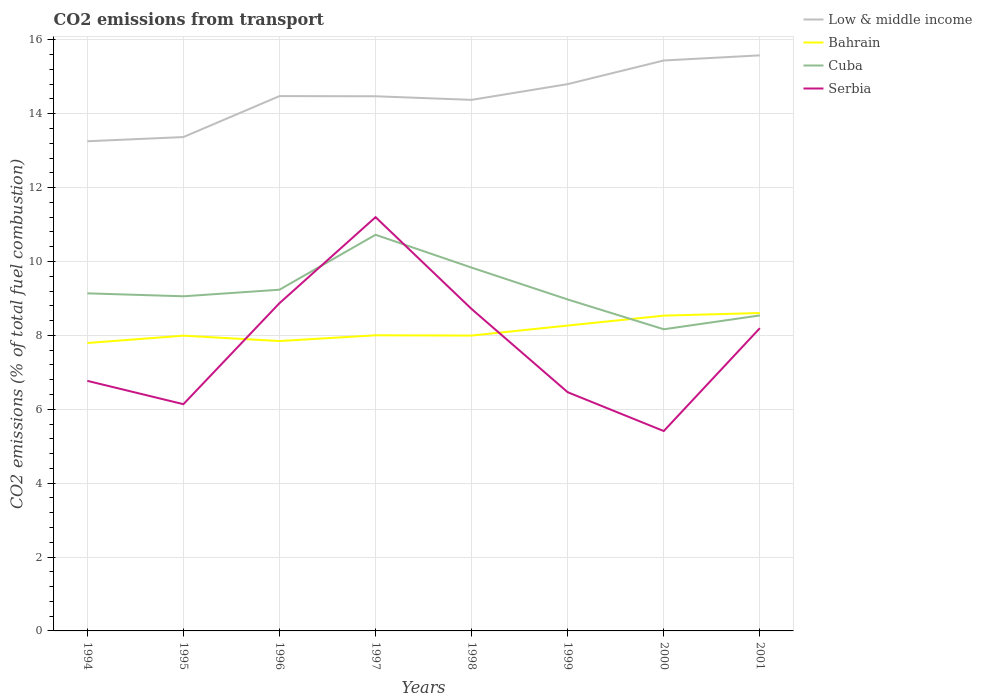Does the line corresponding to Bahrain intersect with the line corresponding to Serbia?
Keep it short and to the point. Yes. Is the number of lines equal to the number of legend labels?
Your answer should be very brief. Yes. Across all years, what is the maximum total CO2 emitted in Bahrain?
Offer a terse response. 7.79. What is the total total CO2 emitted in Serbia in the graph?
Offer a terse response. 2.49. What is the difference between the highest and the second highest total CO2 emitted in Cuba?
Make the answer very short. 2.56. How many years are there in the graph?
Keep it short and to the point. 8. What is the difference between two consecutive major ticks on the Y-axis?
Your response must be concise. 2. Are the values on the major ticks of Y-axis written in scientific E-notation?
Make the answer very short. No. Does the graph contain any zero values?
Make the answer very short. No. How are the legend labels stacked?
Make the answer very short. Vertical. What is the title of the graph?
Offer a very short reply. CO2 emissions from transport. What is the label or title of the Y-axis?
Keep it short and to the point. CO2 emissions (% of total fuel combustion). What is the CO2 emissions (% of total fuel combustion) in Low & middle income in 1994?
Your answer should be very brief. 13.26. What is the CO2 emissions (% of total fuel combustion) of Bahrain in 1994?
Ensure brevity in your answer.  7.79. What is the CO2 emissions (% of total fuel combustion) of Cuba in 1994?
Your answer should be compact. 9.14. What is the CO2 emissions (% of total fuel combustion) in Serbia in 1994?
Your response must be concise. 6.77. What is the CO2 emissions (% of total fuel combustion) of Low & middle income in 1995?
Give a very brief answer. 13.37. What is the CO2 emissions (% of total fuel combustion) of Bahrain in 1995?
Provide a short and direct response. 7.99. What is the CO2 emissions (% of total fuel combustion) in Cuba in 1995?
Ensure brevity in your answer.  9.06. What is the CO2 emissions (% of total fuel combustion) of Serbia in 1995?
Provide a succinct answer. 6.14. What is the CO2 emissions (% of total fuel combustion) in Low & middle income in 1996?
Provide a succinct answer. 14.48. What is the CO2 emissions (% of total fuel combustion) of Bahrain in 1996?
Provide a succinct answer. 7.85. What is the CO2 emissions (% of total fuel combustion) in Cuba in 1996?
Offer a terse response. 9.24. What is the CO2 emissions (% of total fuel combustion) of Serbia in 1996?
Your response must be concise. 8.87. What is the CO2 emissions (% of total fuel combustion) in Low & middle income in 1997?
Ensure brevity in your answer.  14.47. What is the CO2 emissions (% of total fuel combustion) of Bahrain in 1997?
Your answer should be very brief. 8. What is the CO2 emissions (% of total fuel combustion) of Cuba in 1997?
Your response must be concise. 10.72. What is the CO2 emissions (% of total fuel combustion) of Serbia in 1997?
Offer a very short reply. 11.2. What is the CO2 emissions (% of total fuel combustion) in Low & middle income in 1998?
Your answer should be compact. 14.38. What is the CO2 emissions (% of total fuel combustion) of Bahrain in 1998?
Your answer should be compact. 8. What is the CO2 emissions (% of total fuel combustion) in Cuba in 1998?
Make the answer very short. 9.83. What is the CO2 emissions (% of total fuel combustion) of Serbia in 1998?
Make the answer very short. 8.71. What is the CO2 emissions (% of total fuel combustion) in Low & middle income in 1999?
Make the answer very short. 14.8. What is the CO2 emissions (% of total fuel combustion) in Bahrain in 1999?
Keep it short and to the point. 8.27. What is the CO2 emissions (% of total fuel combustion) in Cuba in 1999?
Make the answer very short. 8.97. What is the CO2 emissions (% of total fuel combustion) in Serbia in 1999?
Offer a terse response. 6.46. What is the CO2 emissions (% of total fuel combustion) of Low & middle income in 2000?
Ensure brevity in your answer.  15.44. What is the CO2 emissions (% of total fuel combustion) in Bahrain in 2000?
Make the answer very short. 8.53. What is the CO2 emissions (% of total fuel combustion) in Cuba in 2000?
Offer a very short reply. 8.17. What is the CO2 emissions (% of total fuel combustion) of Serbia in 2000?
Your response must be concise. 5.41. What is the CO2 emissions (% of total fuel combustion) in Low & middle income in 2001?
Give a very brief answer. 15.58. What is the CO2 emissions (% of total fuel combustion) in Bahrain in 2001?
Your response must be concise. 8.61. What is the CO2 emissions (% of total fuel combustion) of Cuba in 2001?
Provide a short and direct response. 8.54. What is the CO2 emissions (% of total fuel combustion) in Serbia in 2001?
Offer a terse response. 8.2. Across all years, what is the maximum CO2 emissions (% of total fuel combustion) in Low & middle income?
Your response must be concise. 15.58. Across all years, what is the maximum CO2 emissions (% of total fuel combustion) in Bahrain?
Give a very brief answer. 8.61. Across all years, what is the maximum CO2 emissions (% of total fuel combustion) in Cuba?
Keep it short and to the point. 10.72. Across all years, what is the maximum CO2 emissions (% of total fuel combustion) in Serbia?
Provide a succinct answer. 11.2. Across all years, what is the minimum CO2 emissions (% of total fuel combustion) of Low & middle income?
Ensure brevity in your answer.  13.26. Across all years, what is the minimum CO2 emissions (% of total fuel combustion) in Bahrain?
Keep it short and to the point. 7.79. Across all years, what is the minimum CO2 emissions (% of total fuel combustion) in Cuba?
Offer a terse response. 8.17. Across all years, what is the minimum CO2 emissions (% of total fuel combustion) of Serbia?
Your answer should be compact. 5.41. What is the total CO2 emissions (% of total fuel combustion) of Low & middle income in the graph?
Your answer should be compact. 115.77. What is the total CO2 emissions (% of total fuel combustion) of Bahrain in the graph?
Provide a short and direct response. 65.04. What is the total CO2 emissions (% of total fuel combustion) in Cuba in the graph?
Offer a very short reply. 73.67. What is the total CO2 emissions (% of total fuel combustion) of Serbia in the graph?
Your answer should be very brief. 61.76. What is the difference between the CO2 emissions (% of total fuel combustion) in Low & middle income in 1994 and that in 1995?
Ensure brevity in your answer.  -0.11. What is the difference between the CO2 emissions (% of total fuel combustion) in Bahrain in 1994 and that in 1995?
Ensure brevity in your answer.  -0.2. What is the difference between the CO2 emissions (% of total fuel combustion) in Cuba in 1994 and that in 1995?
Your response must be concise. 0.08. What is the difference between the CO2 emissions (% of total fuel combustion) of Serbia in 1994 and that in 1995?
Give a very brief answer. 0.63. What is the difference between the CO2 emissions (% of total fuel combustion) in Low & middle income in 1994 and that in 1996?
Your answer should be very brief. -1.22. What is the difference between the CO2 emissions (% of total fuel combustion) of Bahrain in 1994 and that in 1996?
Make the answer very short. -0.05. What is the difference between the CO2 emissions (% of total fuel combustion) of Cuba in 1994 and that in 1996?
Ensure brevity in your answer.  -0.1. What is the difference between the CO2 emissions (% of total fuel combustion) in Serbia in 1994 and that in 1996?
Provide a succinct answer. -2.1. What is the difference between the CO2 emissions (% of total fuel combustion) in Low & middle income in 1994 and that in 1997?
Ensure brevity in your answer.  -1.22. What is the difference between the CO2 emissions (% of total fuel combustion) of Bahrain in 1994 and that in 1997?
Offer a very short reply. -0.21. What is the difference between the CO2 emissions (% of total fuel combustion) in Cuba in 1994 and that in 1997?
Your answer should be very brief. -1.59. What is the difference between the CO2 emissions (% of total fuel combustion) of Serbia in 1994 and that in 1997?
Offer a very short reply. -4.43. What is the difference between the CO2 emissions (% of total fuel combustion) in Low & middle income in 1994 and that in 1998?
Your response must be concise. -1.12. What is the difference between the CO2 emissions (% of total fuel combustion) of Bahrain in 1994 and that in 1998?
Keep it short and to the point. -0.2. What is the difference between the CO2 emissions (% of total fuel combustion) of Cuba in 1994 and that in 1998?
Your answer should be compact. -0.7. What is the difference between the CO2 emissions (% of total fuel combustion) in Serbia in 1994 and that in 1998?
Your answer should be very brief. -1.94. What is the difference between the CO2 emissions (% of total fuel combustion) of Low & middle income in 1994 and that in 1999?
Your answer should be very brief. -1.55. What is the difference between the CO2 emissions (% of total fuel combustion) of Bahrain in 1994 and that in 1999?
Make the answer very short. -0.47. What is the difference between the CO2 emissions (% of total fuel combustion) in Cuba in 1994 and that in 1999?
Ensure brevity in your answer.  0.17. What is the difference between the CO2 emissions (% of total fuel combustion) of Serbia in 1994 and that in 1999?
Ensure brevity in your answer.  0.31. What is the difference between the CO2 emissions (% of total fuel combustion) of Low & middle income in 1994 and that in 2000?
Your response must be concise. -2.19. What is the difference between the CO2 emissions (% of total fuel combustion) of Bahrain in 1994 and that in 2000?
Make the answer very short. -0.74. What is the difference between the CO2 emissions (% of total fuel combustion) in Cuba in 1994 and that in 2000?
Make the answer very short. 0.97. What is the difference between the CO2 emissions (% of total fuel combustion) in Serbia in 1994 and that in 2000?
Keep it short and to the point. 1.36. What is the difference between the CO2 emissions (% of total fuel combustion) of Low & middle income in 1994 and that in 2001?
Your answer should be compact. -2.33. What is the difference between the CO2 emissions (% of total fuel combustion) of Bahrain in 1994 and that in 2001?
Offer a very short reply. -0.81. What is the difference between the CO2 emissions (% of total fuel combustion) in Cuba in 1994 and that in 2001?
Provide a short and direct response. 0.6. What is the difference between the CO2 emissions (% of total fuel combustion) in Serbia in 1994 and that in 2001?
Give a very brief answer. -1.43. What is the difference between the CO2 emissions (% of total fuel combustion) of Low & middle income in 1995 and that in 1996?
Ensure brevity in your answer.  -1.11. What is the difference between the CO2 emissions (% of total fuel combustion) in Bahrain in 1995 and that in 1996?
Your answer should be compact. 0.15. What is the difference between the CO2 emissions (% of total fuel combustion) in Cuba in 1995 and that in 1996?
Your answer should be compact. -0.18. What is the difference between the CO2 emissions (% of total fuel combustion) in Serbia in 1995 and that in 1996?
Your response must be concise. -2.73. What is the difference between the CO2 emissions (% of total fuel combustion) of Low & middle income in 1995 and that in 1997?
Make the answer very short. -1.1. What is the difference between the CO2 emissions (% of total fuel combustion) of Bahrain in 1995 and that in 1997?
Provide a succinct answer. -0.01. What is the difference between the CO2 emissions (% of total fuel combustion) of Cuba in 1995 and that in 1997?
Offer a very short reply. -1.67. What is the difference between the CO2 emissions (% of total fuel combustion) in Serbia in 1995 and that in 1997?
Your response must be concise. -5.06. What is the difference between the CO2 emissions (% of total fuel combustion) in Low & middle income in 1995 and that in 1998?
Provide a short and direct response. -1.01. What is the difference between the CO2 emissions (% of total fuel combustion) of Bahrain in 1995 and that in 1998?
Offer a terse response. -0. What is the difference between the CO2 emissions (% of total fuel combustion) in Cuba in 1995 and that in 1998?
Your response must be concise. -0.78. What is the difference between the CO2 emissions (% of total fuel combustion) in Serbia in 1995 and that in 1998?
Provide a short and direct response. -2.58. What is the difference between the CO2 emissions (% of total fuel combustion) of Low & middle income in 1995 and that in 1999?
Provide a short and direct response. -1.43. What is the difference between the CO2 emissions (% of total fuel combustion) in Bahrain in 1995 and that in 1999?
Make the answer very short. -0.27. What is the difference between the CO2 emissions (% of total fuel combustion) of Cuba in 1995 and that in 1999?
Ensure brevity in your answer.  0.09. What is the difference between the CO2 emissions (% of total fuel combustion) in Serbia in 1995 and that in 1999?
Offer a very short reply. -0.32. What is the difference between the CO2 emissions (% of total fuel combustion) of Low & middle income in 1995 and that in 2000?
Give a very brief answer. -2.07. What is the difference between the CO2 emissions (% of total fuel combustion) in Bahrain in 1995 and that in 2000?
Make the answer very short. -0.54. What is the difference between the CO2 emissions (% of total fuel combustion) of Cuba in 1995 and that in 2000?
Provide a succinct answer. 0.89. What is the difference between the CO2 emissions (% of total fuel combustion) in Serbia in 1995 and that in 2000?
Provide a succinct answer. 0.73. What is the difference between the CO2 emissions (% of total fuel combustion) in Low & middle income in 1995 and that in 2001?
Provide a succinct answer. -2.21. What is the difference between the CO2 emissions (% of total fuel combustion) in Bahrain in 1995 and that in 2001?
Provide a succinct answer. -0.61. What is the difference between the CO2 emissions (% of total fuel combustion) in Cuba in 1995 and that in 2001?
Provide a succinct answer. 0.52. What is the difference between the CO2 emissions (% of total fuel combustion) in Serbia in 1995 and that in 2001?
Your answer should be compact. -2.06. What is the difference between the CO2 emissions (% of total fuel combustion) of Low & middle income in 1996 and that in 1997?
Make the answer very short. 0. What is the difference between the CO2 emissions (% of total fuel combustion) in Bahrain in 1996 and that in 1997?
Your answer should be compact. -0.16. What is the difference between the CO2 emissions (% of total fuel combustion) of Cuba in 1996 and that in 1997?
Provide a short and direct response. -1.49. What is the difference between the CO2 emissions (% of total fuel combustion) of Serbia in 1996 and that in 1997?
Offer a terse response. -2.33. What is the difference between the CO2 emissions (% of total fuel combustion) of Low & middle income in 1996 and that in 1998?
Your answer should be very brief. 0.1. What is the difference between the CO2 emissions (% of total fuel combustion) in Bahrain in 1996 and that in 1998?
Give a very brief answer. -0.15. What is the difference between the CO2 emissions (% of total fuel combustion) in Cuba in 1996 and that in 1998?
Offer a terse response. -0.6. What is the difference between the CO2 emissions (% of total fuel combustion) in Serbia in 1996 and that in 1998?
Make the answer very short. 0.16. What is the difference between the CO2 emissions (% of total fuel combustion) in Low & middle income in 1996 and that in 1999?
Give a very brief answer. -0.32. What is the difference between the CO2 emissions (% of total fuel combustion) in Bahrain in 1996 and that in 1999?
Your response must be concise. -0.42. What is the difference between the CO2 emissions (% of total fuel combustion) in Cuba in 1996 and that in 1999?
Ensure brevity in your answer.  0.26. What is the difference between the CO2 emissions (% of total fuel combustion) in Serbia in 1996 and that in 1999?
Your answer should be compact. 2.41. What is the difference between the CO2 emissions (% of total fuel combustion) in Low & middle income in 1996 and that in 2000?
Make the answer very short. -0.96. What is the difference between the CO2 emissions (% of total fuel combustion) of Bahrain in 1996 and that in 2000?
Give a very brief answer. -0.69. What is the difference between the CO2 emissions (% of total fuel combustion) in Cuba in 1996 and that in 2000?
Offer a terse response. 1.07. What is the difference between the CO2 emissions (% of total fuel combustion) in Serbia in 1996 and that in 2000?
Provide a succinct answer. 3.46. What is the difference between the CO2 emissions (% of total fuel combustion) of Low & middle income in 1996 and that in 2001?
Offer a terse response. -1.1. What is the difference between the CO2 emissions (% of total fuel combustion) in Bahrain in 1996 and that in 2001?
Offer a terse response. -0.76. What is the difference between the CO2 emissions (% of total fuel combustion) in Cuba in 1996 and that in 2001?
Your answer should be very brief. 0.7. What is the difference between the CO2 emissions (% of total fuel combustion) in Serbia in 1996 and that in 2001?
Your answer should be compact. 0.68. What is the difference between the CO2 emissions (% of total fuel combustion) of Low & middle income in 1997 and that in 1998?
Ensure brevity in your answer.  0.1. What is the difference between the CO2 emissions (% of total fuel combustion) in Bahrain in 1997 and that in 1998?
Provide a succinct answer. 0.01. What is the difference between the CO2 emissions (% of total fuel combustion) of Cuba in 1997 and that in 1998?
Your answer should be compact. 0.89. What is the difference between the CO2 emissions (% of total fuel combustion) of Serbia in 1997 and that in 1998?
Keep it short and to the point. 2.49. What is the difference between the CO2 emissions (% of total fuel combustion) in Low & middle income in 1997 and that in 1999?
Offer a very short reply. -0.33. What is the difference between the CO2 emissions (% of total fuel combustion) in Bahrain in 1997 and that in 1999?
Make the answer very short. -0.26. What is the difference between the CO2 emissions (% of total fuel combustion) of Cuba in 1997 and that in 1999?
Your response must be concise. 1.75. What is the difference between the CO2 emissions (% of total fuel combustion) of Serbia in 1997 and that in 1999?
Keep it short and to the point. 4.74. What is the difference between the CO2 emissions (% of total fuel combustion) in Low & middle income in 1997 and that in 2000?
Your answer should be compact. -0.97. What is the difference between the CO2 emissions (% of total fuel combustion) in Bahrain in 1997 and that in 2000?
Make the answer very short. -0.53. What is the difference between the CO2 emissions (% of total fuel combustion) of Cuba in 1997 and that in 2000?
Offer a very short reply. 2.56. What is the difference between the CO2 emissions (% of total fuel combustion) in Serbia in 1997 and that in 2000?
Your answer should be compact. 5.79. What is the difference between the CO2 emissions (% of total fuel combustion) in Low & middle income in 1997 and that in 2001?
Keep it short and to the point. -1.11. What is the difference between the CO2 emissions (% of total fuel combustion) in Bahrain in 1997 and that in 2001?
Provide a succinct answer. -0.6. What is the difference between the CO2 emissions (% of total fuel combustion) of Cuba in 1997 and that in 2001?
Ensure brevity in your answer.  2.18. What is the difference between the CO2 emissions (% of total fuel combustion) of Serbia in 1997 and that in 2001?
Give a very brief answer. 3.01. What is the difference between the CO2 emissions (% of total fuel combustion) in Low & middle income in 1998 and that in 1999?
Your response must be concise. -0.43. What is the difference between the CO2 emissions (% of total fuel combustion) in Bahrain in 1998 and that in 1999?
Your answer should be very brief. -0.27. What is the difference between the CO2 emissions (% of total fuel combustion) in Cuba in 1998 and that in 1999?
Your answer should be very brief. 0.86. What is the difference between the CO2 emissions (% of total fuel combustion) of Serbia in 1998 and that in 1999?
Ensure brevity in your answer.  2.25. What is the difference between the CO2 emissions (% of total fuel combustion) of Low & middle income in 1998 and that in 2000?
Give a very brief answer. -1.07. What is the difference between the CO2 emissions (% of total fuel combustion) of Bahrain in 1998 and that in 2000?
Give a very brief answer. -0.54. What is the difference between the CO2 emissions (% of total fuel combustion) of Cuba in 1998 and that in 2000?
Your answer should be very brief. 1.67. What is the difference between the CO2 emissions (% of total fuel combustion) in Serbia in 1998 and that in 2000?
Your answer should be compact. 3.3. What is the difference between the CO2 emissions (% of total fuel combustion) in Low & middle income in 1998 and that in 2001?
Keep it short and to the point. -1.2. What is the difference between the CO2 emissions (% of total fuel combustion) in Bahrain in 1998 and that in 2001?
Your answer should be very brief. -0.61. What is the difference between the CO2 emissions (% of total fuel combustion) in Cuba in 1998 and that in 2001?
Provide a succinct answer. 1.29. What is the difference between the CO2 emissions (% of total fuel combustion) of Serbia in 1998 and that in 2001?
Provide a short and direct response. 0.52. What is the difference between the CO2 emissions (% of total fuel combustion) of Low & middle income in 1999 and that in 2000?
Provide a succinct answer. -0.64. What is the difference between the CO2 emissions (% of total fuel combustion) in Bahrain in 1999 and that in 2000?
Give a very brief answer. -0.27. What is the difference between the CO2 emissions (% of total fuel combustion) of Cuba in 1999 and that in 2000?
Ensure brevity in your answer.  0.81. What is the difference between the CO2 emissions (% of total fuel combustion) of Serbia in 1999 and that in 2000?
Offer a very short reply. 1.05. What is the difference between the CO2 emissions (% of total fuel combustion) of Low & middle income in 1999 and that in 2001?
Offer a terse response. -0.78. What is the difference between the CO2 emissions (% of total fuel combustion) in Bahrain in 1999 and that in 2001?
Your answer should be very brief. -0.34. What is the difference between the CO2 emissions (% of total fuel combustion) of Cuba in 1999 and that in 2001?
Provide a short and direct response. 0.43. What is the difference between the CO2 emissions (% of total fuel combustion) of Serbia in 1999 and that in 2001?
Ensure brevity in your answer.  -1.73. What is the difference between the CO2 emissions (% of total fuel combustion) of Low & middle income in 2000 and that in 2001?
Your response must be concise. -0.14. What is the difference between the CO2 emissions (% of total fuel combustion) of Bahrain in 2000 and that in 2001?
Make the answer very short. -0.07. What is the difference between the CO2 emissions (% of total fuel combustion) in Cuba in 2000 and that in 2001?
Give a very brief answer. -0.37. What is the difference between the CO2 emissions (% of total fuel combustion) of Serbia in 2000 and that in 2001?
Provide a short and direct response. -2.78. What is the difference between the CO2 emissions (% of total fuel combustion) of Low & middle income in 1994 and the CO2 emissions (% of total fuel combustion) of Bahrain in 1995?
Ensure brevity in your answer.  5.26. What is the difference between the CO2 emissions (% of total fuel combustion) in Low & middle income in 1994 and the CO2 emissions (% of total fuel combustion) in Cuba in 1995?
Your answer should be compact. 4.2. What is the difference between the CO2 emissions (% of total fuel combustion) of Low & middle income in 1994 and the CO2 emissions (% of total fuel combustion) of Serbia in 1995?
Give a very brief answer. 7.12. What is the difference between the CO2 emissions (% of total fuel combustion) of Bahrain in 1994 and the CO2 emissions (% of total fuel combustion) of Cuba in 1995?
Ensure brevity in your answer.  -1.26. What is the difference between the CO2 emissions (% of total fuel combustion) in Bahrain in 1994 and the CO2 emissions (% of total fuel combustion) in Serbia in 1995?
Your answer should be very brief. 1.66. What is the difference between the CO2 emissions (% of total fuel combustion) in Cuba in 1994 and the CO2 emissions (% of total fuel combustion) in Serbia in 1995?
Give a very brief answer. 3. What is the difference between the CO2 emissions (% of total fuel combustion) of Low & middle income in 1994 and the CO2 emissions (% of total fuel combustion) of Bahrain in 1996?
Your answer should be very brief. 5.41. What is the difference between the CO2 emissions (% of total fuel combustion) of Low & middle income in 1994 and the CO2 emissions (% of total fuel combustion) of Cuba in 1996?
Offer a terse response. 4.02. What is the difference between the CO2 emissions (% of total fuel combustion) of Low & middle income in 1994 and the CO2 emissions (% of total fuel combustion) of Serbia in 1996?
Keep it short and to the point. 4.38. What is the difference between the CO2 emissions (% of total fuel combustion) of Bahrain in 1994 and the CO2 emissions (% of total fuel combustion) of Cuba in 1996?
Your answer should be very brief. -1.44. What is the difference between the CO2 emissions (% of total fuel combustion) of Bahrain in 1994 and the CO2 emissions (% of total fuel combustion) of Serbia in 1996?
Offer a very short reply. -1.08. What is the difference between the CO2 emissions (% of total fuel combustion) of Cuba in 1994 and the CO2 emissions (% of total fuel combustion) of Serbia in 1996?
Provide a short and direct response. 0.27. What is the difference between the CO2 emissions (% of total fuel combustion) of Low & middle income in 1994 and the CO2 emissions (% of total fuel combustion) of Bahrain in 1997?
Give a very brief answer. 5.25. What is the difference between the CO2 emissions (% of total fuel combustion) in Low & middle income in 1994 and the CO2 emissions (% of total fuel combustion) in Cuba in 1997?
Ensure brevity in your answer.  2.53. What is the difference between the CO2 emissions (% of total fuel combustion) in Low & middle income in 1994 and the CO2 emissions (% of total fuel combustion) in Serbia in 1997?
Offer a very short reply. 2.05. What is the difference between the CO2 emissions (% of total fuel combustion) of Bahrain in 1994 and the CO2 emissions (% of total fuel combustion) of Cuba in 1997?
Your response must be concise. -2.93. What is the difference between the CO2 emissions (% of total fuel combustion) in Bahrain in 1994 and the CO2 emissions (% of total fuel combustion) in Serbia in 1997?
Keep it short and to the point. -3.41. What is the difference between the CO2 emissions (% of total fuel combustion) of Cuba in 1994 and the CO2 emissions (% of total fuel combustion) of Serbia in 1997?
Ensure brevity in your answer.  -2.06. What is the difference between the CO2 emissions (% of total fuel combustion) in Low & middle income in 1994 and the CO2 emissions (% of total fuel combustion) in Bahrain in 1998?
Provide a succinct answer. 5.26. What is the difference between the CO2 emissions (% of total fuel combustion) of Low & middle income in 1994 and the CO2 emissions (% of total fuel combustion) of Cuba in 1998?
Your answer should be very brief. 3.42. What is the difference between the CO2 emissions (% of total fuel combustion) in Low & middle income in 1994 and the CO2 emissions (% of total fuel combustion) in Serbia in 1998?
Keep it short and to the point. 4.54. What is the difference between the CO2 emissions (% of total fuel combustion) of Bahrain in 1994 and the CO2 emissions (% of total fuel combustion) of Cuba in 1998?
Provide a short and direct response. -2.04. What is the difference between the CO2 emissions (% of total fuel combustion) in Bahrain in 1994 and the CO2 emissions (% of total fuel combustion) in Serbia in 1998?
Offer a very short reply. -0.92. What is the difference between the CO2 emissions (% of total fuel combustion) in Cuba in 1994 and the CO2 emissions (% of total fuel combustion) in Serbia in 1998?
Ensure brevity in your answer.  0.42. What is the difference between the CO2 emissions (% of total fuel combustion) in Low & middle income in 1994 and the CO2 emissions (% of total fuel combustion) in Bahrain in 1999?
Keep it short and to the point. 4.99. What is the difference between the CO2 emissions (% of total fuel combustion) of Low & middle income in 1994 and the CO2 emissions (% of total fuel combustion) of Cuba in 1999?
Your answer should be very brief. 4.28. What is the difference between the CO2 emissions (% of total fuel combustion) in Low & middle income in 1994 and the CO2 emissions (% of total fuel combustion) in Serbia in 1999?
Provide a short and direct response. 6.79. What is the difference between the CO2 emissions (% of total fuel combustion) of Bahrain in 1994 and the CO2 emissions (% of total fuel combustion) of Cuba in 1999?
Ensure brevity in your answer.  -1.18. What is the difference between the CO2 emissions (% of total fuel combustion) in Bahrain in 1994 and the CO2 emissions (% of total fuel combustion) in Serbia in 1999?
Provide a short and direct response. 1.33. What is the difference between the CO2 emissions (% of total fuel combustion) in Cuba in 1994 and the CO2 emissions (% of total fuel combustion) in Serbia in 1999?
Your answer should be very brief. 2.68. What is the difference between the CO2 emissions (% of total fuel combustion) of Low & middle income in 1994 and the CO2 emissions (% of total fuel combustion) of Bahrain in 2000?
Ensure brevity in your answer.  4.72. What is the difference between the CO2 emissions (% of total fuel combustion) in Low & middle income in 1994 and the CO2 emissions (% of total fuel combustion) in Cuba in 2000?
Your response must be concise. 5.09. What is the difference between the CO2 emissions (% of total fuel combustion) of Low & middle income in 1994 and the CO2 emissions (% of total fuel combustion) of Serbia in 2000?
Your response must be concise. 7.84. What is the difference between the CO2 emissions (% of total fuel combustion) in Bahrain in 1994 and the CO2 emissions (% of total fuel combustion) in Cuba in 2000?
Ensure brevity in your answer.  -0.37. What is the difference between the CO2 emissions (% of total fuel combustion) in Bahrain in 1994 and the CO2 emissions (% of total fuel combustion) in Serbia in 2000?
Provide a short and direct response. 2.38. What is the difference between the CO2 emissions (% of total fuel combustion) of Cuba in 1994 and the CO2 emissions (% of total fuel combustion) of Serbia in 2000?
Offer a terse response. 3.73. What is the difference between the CO2 emissions (% of total fuel combustion) of Low & middle income in 1994 and the CO2 emissions (% of total fuel combustion) of Bahrain in 2001?
Offer a very short reply. 4.65. What is the difference between the CO2 emissions (% of total fuel combustion) of Low & middle income in 1994 and the CO2 emissions (% of total fuel combustion) of Cuba in 2001?
Your answer should be compact. 4.71. What is the difference between the CO2 emissions (% of total fuel combustion) of Low & middle income in 1994 and the CO2 emissions (% of total fuel combustion) of Serbia in 2001?
Your response must be concise. 5.06. What is the difference between the CO2 emissions (% of total fuel combustion) of Bahrain in 1994 and the CO2 emissions (% of total fuel combustion) of Cuba in 2001?
Keep it short and to the point. -0.75. What is the difference between the CO2 emissions (% of total fuel combustion) of Bahrain in 1994 and the CO2 emissions (% of total fuel combustion) of Serbia in 2001?
Your answer should be compact. -0.4. What is the difference between the CO2 emissions (% of total fuel combustion) of Cuba in 1994 and the CO2 emissions (% of total fuel combustion) of Serbia in 2001?
Your response must be concise. 0.94. What is the difference between the CO2 emissions (% of total fuel combustion) of Low & middle income in 1995 and the CO2 emissions (% of total fuel combustion) of Bahrain in 1996?
Provide a short and direct response. 5.52. What is the difference between the CO2 emissions (% of total fuel combustion) of Low & middle income in 1995 and the CO2 emissions (% of total fuel combustion) of Cuba in 1996?
Keep it short and to the point. 4.13. What is the difference between the CO2 emissions (% of total fuel combustion) of Low & middle income in 1995 and the CO2 emissions (% of total fuel combustion) of Serbia in 1996?
Your answer should be compact. 4.5. What is the difference between the CO2 emissions (% of total fuel combustion) of Bahrain in 1995 and the CO2 emissions (% of total fuel combustion) of Cuba in 1996?
Provide a succinct answer. -1.24. What is the difference between the CO2 emissions (% of total fuel combustion) in Bahrain in 1995 and the CO2 emissions (% of total fuel combustion) in Serbia in 1996?
Your answer should be very brief. -0.88. What is the difference between the CO2 emissions (% of total fuel combustion) in Cuba in 1995 and the CO2 emissions (% of total fuel combustion) in Serbia in 1996?
Your response must be concise. 0.19. What is the difference between the CO2 emissions (% of total fuel combustion) in Low & middle income in 1995 and the CO2 emissions (% of total fuel combustion) in Bahrain in 1997?
Keep it short and to the point. 5.37. What is the difference between the CO2 emissions (% of total fuel combustion) of Low & middle income in 1995 and the CO2 emissions (% of total fuel combustion) of Cuba in 1997?
Provide a short and direct response. 2.64. What is the difference between the CO2 emissions (% of total fuel combustion) of Low & middle income in 1995 and the CO2 emissions (% of total fuel combustion) of Serbia in 1997?
Offer a very short reply. 2.17. What is the difference between the CO2 emissions (% of total fuel combustion) in Bahrain in 1995 and the CO2 emissions (% of total fuel combustion) in Cuba in 1997?
Offer a terse response. -2.73. What is the difference between the CO2 emissions (% of total fuel combustion) in Bahrain in 1995 and the CO2 emissions (% of total fuel combustion) in Serbia in 1997?
Provide a succinct answer. -3.21. What is the difference between the CO2 emissions (% of total fuel combustion) of Cuba in 1995 and the CO2 emissions (% of total fuel combustion) of Serbia in 1997?
Give a very brief answer. -2.14. What is the difference between the CO2 emissions (% of total fuel combustion) of Low & middle income in 1995 and the CO2 emissions (% of total fuel combustion) of Bahrain in 1998?
Your response must be concise. 5.37. What is the difference between the CO2 emissions (% of total fuel combustion) of Low & middle income in 1995 and the CO2 emissions (% of total fuel combustion) of Cuba in 1998?
Make the answer very short. 3.53. What is the difference between the CO2 emissions (% of total fuel combustion) in Low & middle income in 1995 and the CO2 emissions (% of total fuel combustion) in Serbia in 1998?
Provide a succinct answer. 4.65. What is the difference between the CO2 emissions (% of total fuel combustion) of Bahrain in 1995 and the CO2 emissions (% of total fuel combustion) of Cuba in 1998?
Provide a succinct answer. -1.84. What is the difference between the CO2 emissions (% of total fuel combustion) of Bahrain in 1995 and the CO2 emissions (% of total fuel combustion) of Serbia in 1998?
Ensure brevity in your answer.  -0.72. What is the difference between the CO2 emissions (% of total fuel combustion) of Cuba in 1995 and the CO2 emissions (% of total fuel combustion) of Serbia in 1998?
Your answer should be very brief. 0.34. What is the difference between the CO2 emissions (% of total fuel combustion) in Low & middle income in 1995 and the CO2 emissions (% of total fuel combustion) in Bahrain in 1999?
Provide a short and direct response. 5.1. What is the difference between the CO2 emissions (% of total fuel combustion) of Low & middle income in 1995 and the CO2 emissions (% of total fuel combustion) of Cuba in 1999?
Your answer should be compact. 4.4. What is the difference between the CO2 emissions (% of total fuel combustion) of Low & middle income in 1995 and the CO2 emissions (% of total fuel combustion) of Serbia in 1999?
Ensure brevity in your answer.  6.91. What is the difference between the CO2 emissions (% of total fuel combustion) in Bahrain in 1995 and the CO2 emissions (% of total fuel combustion) in Cuba in 1999?
Provide a succinct answer. -0.98. What is the difference between the CO2 emissions (% of total fuel combustion) of Bahrain in 1995 and the CO2 emissions (% of total fuel combustion) of Serbia in 1999?
Provide a succinct answer. 1.53. What is the difference between the CO2 emissions (% of total fuel combustion) of Cuba in 1995 and the CO2 emissions (% of total fuel combustion) of Serbia in 1999?
Provide a succinct answer. 2.6. What is the difference between the CO2 emissions (% of total fuel combustion) of Low & middle income in 1995 and the CO2 emissions (% of total fuel combustion) of Bahrain in 2000?
Your answer should be compact. 4.83. What is the difference between the CO2 emissions (% of total fuel combustion) in Low & middle income in 1995 and the CO2 emissions (% of total fuel combustion) in Cuba in 2000?
Your answer should be compact. 5.2. What is the difference between the CO2 emissions (% of total fuel combustion) of Low & middle income in 1995 and the CO2 emissions (% of total fuel combustion) of Serbia in 2000?
Your answer should be very brief. 7.96. What is the difference between the CO2 emissions (% of total fuel combustion) of Bahrain in 1995 and the CO2 emissions (% of total fuel combustion) of Cuba in 2000?
Ensure brevity in your answer.  -0.17. What is the difference between the CO2 emissions (% of total fuel combustion) in Bahrain in 1995 and the CO2 emissions (% of total fuel combustion) in Serbia in 2000?
Offer a terse response. 2.58. What is the difference between the CO2 emissions (% of total fuel combustion) in Cuba in 1995 and the CO2 emissions (% of total fuel combustion) in Serbia in 2000?
Your answer should be compact. 3.65. What is the difference between the CO2 emissions (% of total fuel combustion) in Low & middle income in 1995 and the CO2 emissions (% of total fuel combustion) in Bahrain in 2001?
Give a very brief answer. 4.76. What is the difference between the CO2 emissions (% of total fuel combustion) of Low & middle income in 1995 and the CO2 emissions (% of total fuel combustion) of Cuba in 2001?
Make the answer very short. 4.83. What is the difference between the CO2 emissions (% of total fuel combustion) in Low & middle income in 1995 and the CO2 emissions (% of total fuel combustion) in Serbia in 2001?
Give a very brief answer. 5.17. What is the difference between the CO2 emissions (% of total fuel combustion) in Bahrain in 1995 and the CO2 emissions (% of total fuel combustion) in Cuba in 2001?
Give a very brief answer. -0.55. What is the difference between the CO2 emissions (% of total fuel combustion) of Bahrain in 1995 and the CO2 emissions (% of total fuel combustion) of Serbia in 2001?
Your response must be concise. -0.2. What is the difference between the CO2 emissions (% of total fuel combustion) of Cuba in 1995 and the CO2 emissions (% of total fuel combustion) of Serbia in 2001?
Ensure brevity in your answer.  0.86. What is the difference between the CO2 emissions (% of total fuel combustion) in Low & middle income in 1996 and the CO2 emissions (% of total fuel combustion) in Bahrain in 1997?
Keep it short and to the point. 6.48. What is the difference between the CO2 emissions (% of total fuel combustion) in Low & middle income in 1996 and the CO2 emissions (% of total fuel combustion) in Cuba in 1997?
Keep it short and to the point. 3.75. What is the difference between the CO2 emissions (% of total fuel combustion) of Low & middle income in 1996 and the CO2 emissions (% of total fuel combustion) of Serbia in 1997?
Offer a terse response. 3.28. What is the difference between the CO2 emissions (% of total fuel combustion) of Bahrain in 1996 and the CO2 emissions (% of total fuel combustion) of Cuba in 1997?
Keep it short and to the point. -2.88. What is the difference between the CO2 emissions (% of total fuel combustion) of Bahrain in 1996 and the CO2 emissions (% of total fuel combustion) of Serbia in 1997?
Ensure brevity in your answer.  -3.35. What is the difference between the CO2 emissions (% of total fuel combustion) in Cuba in 1996 and the CO2 emissions (% of total fuel combustion) in Serbia in 1997?
Offer a terse response. -1.96. What is the difference between the CO2 emissions (% of total fuel combustion) of Low & middle income in 1996 and the CO2 emissions (% of total fuel combustion) of Bahrain in 1998?
Ensure brevity in your answer.  6.48. What is the difference between the CO2 emissions (% of total fuel combustion) of Low & middle income in 1996 and the CO2 emissions (% of total fuel combustion) of Cuba in 1998?
Provide a short and direct response. 4.64. What is the difference between the CO2 emissions (% of total fuel combustion) in Low & middle income in 1996 and the CO2 emissions (% of total fuel combustion) in Serbia in 1998?
Provide a short and direct response. 5.76. What is the difference between the CO2 emissions (% of total fuel combustion) in Bahrain in 1996 and the CO2 emissions (% of total fuel combustion) in Cuba in 1998?
Your answer should be compact. -1.99. What is the difference between the CO2 emissions (% of total fuel combustion) in Bahrain in 1996 and the CO2 emissions (% of total fuel combustion) in Serbia in 1998?
Your response must be concise. -0.87. What is the difference between the CO2 emissions (% of total fuel combustion) in Cuba in 1996 and the CO2 emissions (% of total fuel combustion) in Serbia in 1998?
Provide a short and direct response. 0.52. What is the difference between the CO2 emissions (% of total fuel combustion) in Low & middle income in 1996 and the CO2 emissions (% of total fuel combustion) in Bahrain in 1999?
Ensure brevity in your answer.  6.21. What is the difference between the CO2 emissions (% of total fuel combustion) in Low & middle income in 1996 and the CO2 emissions (% of total fuel combustion) in Cuba in 1999?
Make the answer very short. 5.51. What is the difference between the CO2 emissions (% of total fuel combustion) in Low & middle income in 1996 and the CO2 emissions (% of total fuel combustion) in Serbia in 1999?
Offer a terse response. 8.02. What is the difference between the CO2 emissions (% of total fuel combustion) in Bahrain in 1996 and the CO2 emissions (% of total fuel combustion) in Cuba in 1999?
Provide a succinct answer. -1.13. What is the difference between the CO2 emissions (% of total fuel combustion) in Bahrain in 1996 and the CO2 emissions (% of total fuel combustion) in Serbia in 1999?
Make the answer very short. 1.39. What is the difference between the CO2 emissions (% of total fuel combustion) of Cuba in 1996 and the CO2 emissions (% of total fuel combustion) of Serbia in 1999?
Provide a succinct answer. 2.78. What is the difference between the CO2 emissions (% of total fuel combustion) of Low & middle income in 1996 and the CO2 emissions (% of total fuel combustion) of Bahrain in 2000?
Give a very brief answer. 5.94. What is the difference between the CO2 emissions (% of total fuel combustion) in Low & middle income in 1996 and the CO2 emissions (% of total fuel combustion) in Cuba in 2000?
Keep it short and to the point. 6.31. What is the difference between the CO2 emissions (% of total fuel combustion) in Low & middle income in 1996 and the CO2 emissions (% of total fuel combustion) in Serbia in 2000?
Make the answer very short. 9.07. What is the difference between the CO2 emissions (% of total fuel combustion) of Bahrain in 1996 and the CO2 emissions (% of total fuel combustion) of Cuba in 2000?
Keep it short and to the point. -0.32. What is the difference between the CO2 emissions (% of total fuel combustion) of Bahrain in 1996 and the CO2 emissions (% of total fuel combustion) of Serbia in 2000?
Offer a terse response. 2.44. What is the difference between the CO2 emissions (% of total fuel combustion) in Cuba in 1996 and the CO2 emissions (% of total fuel combustion) in Serbia in 2000?
Your answer should be compact. 3.83. What is the difference between the CO2 emissions (% of total fuel combustion) of Low & middle income in 1996 and the CO2 emissions (% of total fuel combustion) of Bahrain in 2001?
Ensure brevity in your answer.  5.87. What is the difference between the CO2 emissions (% of total fuel combustion) of Low & middle income in 1996 and the CO2 emissions (% of total fuel combustion) of Cuba in 2001?
Keep it short and to the point. 5.94. What is the difference between the CO2 emissions (% of total fuel combustion) of Low & middle income in 1996 and the CO2 emissions (% of total fuel combustion) of Serbia in 2001?
Keep it short and to the point. 6.28. What is the difference between the CO2 emissions (% of total fuel combustion) in Bahrain in 1996 and the CO2 emissions (% of total fuel combustion) in Cuba in 2001?
Your answer should be very brief. -0.69. What is the difference between the CO2 emissions (% of total fuel combustion) of Bahrain in 1996 and the CO2 emissions (% of total fuel combustion) of Serbia in 2001?
Your response must be concise. -0.35. What is the difference between the CO2 emissions (% of total fuel combustion) in Cuba in 1996 and the CO2 emissions (% of total fuel combustion) in Serbia in 2001?
Keep it short and to the point. 1.04. What is the difference between the CO2 emissions (% of total fuel combustion) of Low & middle income in 1997 and the CO2 emissions (% of total fuel combustion) of Bahrain in 1998?
Give a very brief answer. 6.48. What is the difference between the CO2 emissions (% of total fuel combustion) in Low & middle income in 1997 and the CO2 emissions (% of total fuel combustion) in Cuba in 1998?
Provide a short and direct response. 4.64. What is the difference between the CO2 emissions (% of total fuel combustion) in Low & middle income in 1997 and the CO2 emissions (% of total fuel combustion) in Serbia in 1998?
Make the answer very short. 5.76. What is the difference between the CO2 emissions (% of total fuel combustion) of Bahrain in 1997 and the CO2 emissions (% of total fuel combustion) of Cuba in 1998?
Give a very brief answer. -1.83. What is the difference between the CO2 emissions (% of total fuel combustion) in Bahrain in 1997 and the CO2 emissions (% of total fuel combustion) in Serbia in 1998?
Offer a terse response. -0.71. What is the difference between the CO2 emissions (% of total fuel combustion) in Cuba in 1997 and the CO2 emissions (% of total fuel combustion) in Serbia in 1998?
Your answer should be compact. 2.01. What is the difference between the CO2 emissions (% of total fuel combustion) of Low & middle income in 1997 and the CO2 emissions (% of total fuel combustion) of Bahrain in 1999?
Keep it short and to the point. 6.21. What is the difference between the CO2 emissions (% of total fuel combustion) in Low & middle income in 1997 and the CO2 emissions (% of total fuel combustion) in Cuba in 1999?
Offer a very short reply. 5.5. What is the difference between the CO2 emissions (% of total fuel combustion) of Low & middle income in 1997 and the CO2 emissions (% of total fuel combustion) of Serbia in 1999?
Provide a short and direct response. 8.01. What is the difference between the CO2 emissions (% of total fuel combustion) of Bahrain in 1997 and the CO2 emissions (% of total fuel combustion) of Cuba in 1999?
Offer a terse response. -0.97. What is the difference between the CO2 emissions (% of total fuel combustion) of Bahrain in 1997 and the CO2 emissions (% of total fuel combustion) of Serbia in 1999?
Keep it short and to the point. 1.54. What is the difference between the CO2 emissions (% of total fuel combustion) in Cuba in 1997 and the CO2 emissions (% of total fuel combustion) in Serbia in 1999?
Provide a succinct answer. 4.26. What is the difference between the CO2 emissions (% of total fuel combustion) of Low & middle income in 1997 and the CO2 emissions (% of total fuel combustion) of Bahrain in 2000?
Provide a short and direct response. 5.94. What is the difference between the CO2 emissions (% of total fuel combustion) in Low & middle income in 1997 and the CO2 emissions (% of total fuel combustion) in Cuba in 2000?
Give a very brief answer. 6.31. What is the difference between the CO2 emissions (% of total fuel combustion) of Low & middle income in 1997 and the CO2 emissions (% of total fuel combustion) of Serbia in 2000?
Keep it short and to the point. 9.06. What is the difference between the CO2 emissions (% of total fuel combustion) of Bahrain in 1997 and the CO2 emissions (% of total fuel combustion) of Cuba in 2000?
Provide a short and direct response. -0.16. What is the difference between the CO2 emissions (% of total fuel combustion) in Bahrain in 1997 and the CO2 emissions (% of total fuel combustion) in Serbia in 2000?
Provide a short and direct response. 2.59. What is the difference between the CO2 emissions (% of total fuel combustion) in Cuba in 1997 and the CO2 emissions (% of total fuel combustion) in Serbia in 2000?
Your answer should be compact. 5.31. What is the difference between the CO2 emissions (% of total fuel combustion) in Low & middle income in 1997 and the CO2 emissions (% of total fuel combustion) in Bahrain in 2001?
Your response must be concise. 5.87. What is the difference between the CO2 emissions (% of total fuel combustion) in Low & middle income in 1997 and the CO2 emissions (% of total fuel combustion) in Cuba in 2001?
Offer a terse response. 5.93. What is the difference between the CO2 emissions (% of total fuel combustion) in Low & middle income in 1997 and the CO2 emissions (% of total fuel combustion) in Serbia in 2001?
Offer a very short reply. 6.28. What is the difference between the CO2 emissions (% of total fuel combustion) in Bahrain in 1997 and the CO2 emissions (% of total fuel combustion) in Cuba in 2001?
Make the answer very short. -0.54. What is the difference between the CO2 emissions (% of total fuel combustion) in Bahrain in 1997 and the CO2 emissions (% of total fuel combustion) in Serbia in 2001?
Your answer should be compact. -0.19. What is the difference between the CO2 emissions (% of total fuel combustion) in Cuba in 1997 and the CO2 emissions (% of total fuel combustion) in Serbia in 2001?
Your answer should be very brief. 2.53. What is the difference between the CO2 emissions (% of total fuel combustion) in Low & middle income in 1998 and the CO2 emissions (% of total fuel combustion) in Bahrain in 1999?
Your answer should be compact. 6.11. What is the difference between the CO2 emissions (% of total fuel combustion) of Low & middle income in 1998 and the CO2 emissions (% of total fuel combustion) of Cuba in 1999?
Make the answer very short. 5.4. What is the difference between the CO2 emissions (% of total fuel combustion) of Low & middle income in 1998 and the CO2 emissions (% of total fuel combustion) of Serbia in 1999?
Your response must be concise. 7.91. What is the difference between the CO2 emissions (% of total fuel combustion) in Bahrain in 1998 and the CO2 emissions (% of total fuel combustion) in Cuba in 1999?
Offer a terse response. -0.98. What is the difference between the CO2 emissions (% of total fuel combustion) in Bahrain in 1998 and the CO2 emissions (% of total fuel combustion) in Serbia in 1999?
Offer a terse response. 1.53. What is the difference between the CO2 emissions (% of total fuel combustion) in Cuba in 1998 and the CO2 emissions (% of total fuel combustion) in Serbia in 1999?
Ensure brevity in your answer.  3.37. What is the difference between the CO2 emissions (% of total fuel combustion) of Low & middle income in 1998 and the CO2 emissions (% of total fuel combustion) of Bahrain in 2000?
Offer a very short reply. 5.84. What is the difference between the CO2 emissions (% of total fuel combustion) of Low & middle income in 1998 and the CO2 emissions (% of total fuel combustion) of Cuba in 2000?
Your response must be concise. 6.21. What is the difference between the CO2 emissions (% of total fuel combustion) of Low & middle income in 1998 and the CO2 emissions (% of total fuel combustion) of Serbia in 2000?
Make the answer very short. 8.97. What is the difference between the CO2 emissions (% of total fuel combustion) in Bahrain in 1998 and the CO2 emissions (% of total fuel combustion) in Cuba in 2000?
Keep it short and to the point. -0.17. What is the difference between the CO2 emissions (% of total fuel combustion) in Bahrain in 1998 and the CO2 emissions (% of total fuel combustion) in Serbia in 2000?
Provide a succinct answer. 2.58. What is the difference between the CO2 emissions (% of total fuel combustion) of Cuba in 1998 and the CO2 emissions (% of total fuel combustion) of Serbia in 2000?
Make the answer very short. 4.42. What is the difference between the CO2 emissions (% of total fuel combustion) in Low & middle income in 1998 and the CO2 emissions (% of total fuel combustion) in Bahrain in 2001?
Offer a terse response. 5.77. What is the difference between the CO2 emissions (% of total fuel combustion) in Low & middle income in 1998 and the CO2 emissions (% of total fuel combustion) in Cuba in 2001?
Your answer should be very brief. 5.84. What is the difference between the CO2 emissions (% of total fuel combustion) of Low & middle income in 1998 and the CO2 emissions (% of total fuel combustion) of Serbia in 2001?
Provide a succinct answer. 6.18. What is the difference between the CO2 emissions (% of total fuel combustion) of Bahrain in 1998 and the CO2 emissions (% of total fuel combustion) of Cuba in 2001?
Provide a succinct answer. -0.54. What is the difference between the CO2 emissions (% of total fuel combustion) of Bahrain in 1998 and the CO2 emissions (% of total fuel combustion) of Serbia in 2001?
Your answer should be very brief. -0.2. What is the difference between the CO2 emissions (% of total fuel combustion) in Cuba in 1998 and the CO2 emissions (% of total fuel combustion) in Serbia in 2001?
Provide a succinct answer. 1.64. What is the difference between the CO2 emissions (% of total fuel combustion) of Low & middle income in 1999 and the CO2 emissions (% of total fuel combustion) of Bahrain in 2000?
Provide a short and direct response. 6.27. What is the difference between the CO2 emissions (% of total fuel combustion) in Low & middle income in 1999 and the CO2 emissions (% of total fuel combustion) in Cuba in 2000?
Keep it short and to the point. 6.64. What is the difference between the CO2 emissions (% of total fuel combustion) in Low & middle income in 1999 and the CO2 emissions (% of total fuel combustion) in Serbia in 2000?
Provide a succinct answer. 9.39. What is the difference between the CO2 emissions (% of total fuel combustion) in Bahrain in 1999 and the CO2 emissions (% of total fuel combustion) in Cuba in 2000?
Keep it short and to the point. 0.1. What is the difference between the CO2 emissions (% of total fuel combustion) in Bahrain in 1999 and the CO2 emissions (% of total fuel combustion) in Serbia in 2000?
Give a very brief answer. 2.86. What is the difference between the CO2 emissions (% of total fuel combustion) in Cuba in 1999 and the CO2 emissions (% of total fuel combustion) in Serbia in 2000?
Give a very brief answer. 3.56. What is the difference between the CO2 emissions (% of total fuel combustion) in Low & middle income in 1999 and the CO2 emissions (% of total fuel combustion) in Bahrain in 2001?
Give a very brief answer. 6.2. What is the difference between the CO2 emissions (% of total fuel combustion) of Low & middle income in 1999 and the CO2 emissions (% of total fuel combustion) of Cuba in 2001?
Offer a terse response. 6.26. What is the difference between the CO2 emissions (% of total fuel combustion) in Low & middle income in 1999 and the CO2 emissions (% of total fuel combustion) in Serbia in 2001?
Provide a short and direct response. 6.61. What is the difference between the CO2 emissions (% of total fuel combustion) in Bahrain in 1999 and the CO2 emissions (% of total fuel combustion) in Cuba in 2001?
Ensure brevity in your answer.  -0.27. What is the difference between the CO2 emissions (% of total fuel combustion) of Bahrain in 1999 and the CO2 emissions (% of total fuel combustion) of Serbia in 2001?
Make the answer very short. 0.07. What is the difference between the CO2 emissions (% of total fuel combustion) in Cuba in 1999 and the CO2 emissions (% of total fuel combustion) in Serbia in 2001?
Your answer should be compact. 0.78. What is the difference between the CO2 emissions (% of total fuel combustion) in Low & middle income in 2000 and the CO2 emissions (% of total fuel combustion) in Bahrain in 2001?
Your answer should be very brief. 6.84. What is the difference between the CO2 emissions (% of total fuel combustion) of Low & middle income in 2000 and the CO2 emissions (% of total fuel combustion) of Cuba in 2001?
Provide a short and direct response. 6.9. What is the difference between the CO2 emissions (% of total fuel combustion) of Low & middle income in 2000 and the CO2 emissions (% of total fuel combustion) of Serbia in 2001?
Your answer should be very brief. 7.25. What is the difference between the CO2 emissions (% of total fuel combustion) of Bahrain in 2000 and the CO2 emissions (% of total fuel combustion) of Cuba in 2001?
Your answer should be compact. -0.01. What is the difference between the CO2 emissions (% of total fuel combustion) in Bahrain in 2000 and the CO2 emissions (% of total fuel combustion) in Serbia in 2001?
Your answer should be very brief. 0.34. What is the difference between the CO2 emissions (% of total fuel combustion) in Cuba in 2000 and the CO2 emissions (% of total fuel combustion) in Serbia in 2001?
Keep it short and to the point. -0.03. What is the average CO2 emissions (% of total fuel combustion) of Low & middle income per year?
Make the answer very short. 14.47. What is the average CO2 emissions (% of total fuel combustion) in Bahrain per year?
Offer a very short reply. 8.13. What is the average CO2 emissions (% of total fuel combustion) in Cuba per year?
Keep it short and to the point. 9.21. What is the average CO2 emissions (% of total fuel combustion) of Serbia per year?
Keep it short and to the point. 7.72. In the year 1994, what is the difference between the CO2 emissions (% of total fuel combustion) of Low & middle income and CO2 emissions (% of total fuel combustion) of Bahrain?
Make the answer very short. 5.46. In the year 1994, what is the difference between the CO2 emissions (% of total fuel combustion) in Low & middle income and CO2 emissions (% of total fuel combustion) in Cuba?
Give a very brief answer. 4.12. In the year 1994, what is the difference between the CO2 emissions (% of total fuel combustion) of Low & middle income and CO2 emissions (% of total fuel combustion) of Serbia?
Make the answer very short. 6.49. In the year 1994, what is the difference between the CO2 emissions (% of total fuel combustion) of Bahrain and CO2 emissions (% of total fuel combustion) of Cuba?
Provide a succinct answer. -1.34. In the year 1994, what is the difference between the CO2 emissions (% of total fuel combustion) in Bahrain and CO2 emissions (% of total fuel combustion) in Serbia?
Make the answer very short. 1.02. In the year 1994, what is the difference between the CO2 emissions (% of total fuel combustion) in Cuba and CO2 emissions (% of total fuel combustion) in Serbia?
Give a very brief answer. 2.37. In the year 1995, what is the difference between the CO2 emissions (% of total fuel combustion) in Low & middle income and CO2 emissions (% of total fuel combustion) in Bahrain?
Provide a succinct answer. 5.38. In the year 1995, what is the difference between the CO2 emissions (% of total fuel combustion) in Low & middle income and CO2 emissions (% of total fuel combustion) in Cuba?
Provide a succinct answer. 4.31. In the year 1995, what is the difference between the CO2 emissions (% of total fuel combustion) of Low & middle income and CO2 emissions (% of total fuel combustion) of Serbia?
Keep it short and to the point. 7.23. In the year 1995, what is the difference between the CO2 emissions (% of total fuel combustion) in Bahrain and CO2 emissions (% of total fuel combustion) in Cuba?
Give a very brief answer. -1.07. In the year 1995, what is the difference between the CO2 emissions (% of total fuel combustion) of Bahrain and CO2 emissions (% of total fuel combustion) of Serbia?
Provide a short and direct response. 1.85. In the year 1995, what is the difference between the CO2 emissions (% of total fuel combustion) of Cuba and CO2 emissions (% of total fuel combustion) of Serbia?
Make the answer very short. 2.92. In the year 1996, what is the difference between the CO2 emissions (% of total fuel combustion) of Low & middle income and CO2 emissions (% of total fuel combustion) of Bahrain?
Your answer should be very brief. 6.63. In the year 1996, what is the difference between the CO2 emissions (% of total fuel combustion) of Low & middle income and CO2 emissions (% of total fuel combustion) of Cuba?
Give a very brief answer. 5.24. In the year 1996, what is the difference between the CO2 emissions (% of total fuel combustion) in Low & middle income and CO2 emissions (% of total fuel combustion) in Serbia?
Your response must be concise. 5.61. In the year 1996, what is the difference between the CO2 emissions (% of total fuel combustion) of Bahrain and CO2 emissions (% of total fuel combustion) of Cuba?
Give a very brief answer. -1.39. In the year 1996, what is the difference between the CO2 emissions (% of total fuel combustion) of Bahrain and CO2 emissions (% of total fuel combustion) of Serbia?
Offer a terse response. -1.03. In the year 1996, what is the difference between the CO2 emissions (% of total fuel combustion) of Cuba and CO2 emissions (% of total fuel combustion) of Serbia?
Your response must be concise. 0.36. In the year 1997, what is the difference between the CO2 emissions (% of total fuel combustion) in Low & middle income and CO2 emissions (% of total fuel combustion) in Bahrain?
Give a very brief answer. 6.47. In the year 1997, what is the difference between the CO2 emissions (% of total fuel combustion) in Low & middle income and CO2 emissions (% of total fuel combustion) in Cuba?
Give a very brief answer. 3.75. In the year 1997, what is the difference between the CO2 emissions (% of total fuel combustion) in Low & middle income and CO2 emissions (% of total fuel combustion) in Serbia?
Make the answer very short. 3.27. In the year 1997, what is the difference between the CO2 emissions (% of total fuel combustion) of Bahrain and CO2 emissions (% of total fuel combustion) of Cuba?
Provide a succinct answer. -2.72. In the year 1997, what is the difference between the CO2 emissions (% of total fuel combustion) of Bahrain and CO2 emissions (% of total fuel combustion) of Serbia?
Ensure brevity in your answer.  -3.2. In the year 1997, what is the difference between the CO2 emissions (% of total fuel combustion) in Cuba and CO2 emissions (% of total fuel combustion) in Serbia?
Offer a very short reply. -0.48. In the year 1998, what is the difference between the CO2 emissions (% of total fuel combustion) in Low & middle income and CO2 emissions (% of total fuel combustion) in Bahrain?
Your answer should be compact. 6.38. In the year 1998, what is the difference between the CO2 emissions (% of total fuel combustion) in Low & middle income and CO2 emissions (% of total fuel combustion) in Cuba?
Keep it short and to the point. 4.54. In the year 1998, what is the difference between the CO2 emissions (% of total fuel combustion) in Low & middle income and CO2 emissions (% of total fuel combustion) in Serbia?
Keep it short and to the point. 5.66. In the year 1998, what is the difference between the CO2 emissions (% of total fuel combustion) of Bahrain and CO2 emissions (% of total fuel combustion) of Cuba?
Provide a succinct answer. -1.84. In the year 1998, what is the difference between the CO2 emissions (% of total fuel combustion) in Bahrain and CO2 emissions (% of total fuel combustion) in Serbia?
Provide a succinct answer. -0.72. In the year 1998, what is the difference between the CO2 emissions (% of total fuel combustion) of Cuba and CO2 emissions (% of total fuel combustion) of Serbia?
Your answer should be very brief. 1.12. In the year 1999, what is the difference between the CO2 emissions (% of total fuel combustion) of Low & middle income and CO2 emissions (% of total fuel combustion) of Bahrain?
Your response must be concise. 6.54. In the year 1999, what is the difference between the CO2 emissions (% of total fuel combustion) in Low & middle income and CO2 emissions (% of total fuel combustion) in Cuba?
Your response must be concise. 5.83. In the year 1999, what is the difference between the CO2 emissions (% of total fuel combustion) of Low & middle income and CO2 emissions (% of total fuel combustion) of Serbia?
Your response must be concise. 8.34. In the year 1999, what is the difference between the CO2 emissions (% of total fuel combustion) of Bahrain and CO2 emissions (% of total fuel combustion) of Cuba?
Your response must be concise. -0.71. In the year 1999, what is the difference between the CO2 emissions (% of total fuel combustion) of Bahrain and CO2 emissions (% of total fuel combustion) of Serbia?
Keep it short and to the point. 1.8. In the year 1999, what is the difference between the CO2 emissions (% of total fuel combustion) of Cuba and CO2 emissions (% of total fuel combustion) of Serbia?
Offer a terse response. 2.51. In the year 2000, what is the difference between the CO2 emissions (% of total fuel combustion) of Low & middle income and CO2 emissions (% of total fuel combustion) of Bahrain?
Provide a short and direct response. 6.91. In the year 2000, what is the difference between the CO2 emissions (% of total fuel combustion) in Low & middle income and CO2 emissions (% of total fuel combustion) in Cuba?
Your answer should be very brief. 7.28. In the year 2000, what is the difference between the CO2 emissions (% of total fuel combustion) of Low & middle income and CO2 emissions (% of total fuel combustion) of Serbia?
Your response must be concise. 10.03. In the year 2000, what is the difference between the CO2 emissions (% of total fuel combustion) in Bahrain and CO2 emissions (% of total fuel combustion) in Cuba?
Keep it short and to the point. 0.37. In the year 2000, what is the difference between the CO2 emissions (% of total fuel combustion) of Bahrain and CO2 emissions (% of total fuel combustion) of Serbia?
Make the answer very short. 3.12. In the year 2000, what is the difference between the CO2 emissions (% of total fuel combustion) in Cuba and CO2 emissions (% of total fuel combustion) in Serbia?
Ensure brevity in your answer.  2.75. In the year 2001, what is the difference between the CO2 emissions (% of total fuel combustion) in Low & middle income and CO2 emissions (% of total fuel combustion) in Bahrain?
Make the answer very short. 6.97. In the year 2001, what is the difference between the CO2 emissions (% of total fuel combustion) of Low & middle income and CO2 emissions (% of total fuel combustion) of Cuba?
Make the answer very short. 7.04. In the year 2001, what is the difference between the CO2 emissions (% of total fuel combustion) of Low & middle income and CO2 emissions (% of total fuel combustion) of Serbia?
Ensure brevity in your answer.  7.38. In the year 2001, what is the difference between the CO2 emissions (% of total fuel combustion) in Bahrain and CO2 emissions (% of total fuel combustion) in Cuba?
Give a very brief answer. 0.07. In the year 2001, what is the difference between the CO2 emissions (% of total fuel combustion) of Bahrain and CO2 emissions (% of total fuel combustion) of Serbia?
Your response must be concise. 0.41. In the year 2001, what is the difference between the CO2 emissions (% of total fuel combustion) in Cuba and CO2 emissions (% of total fuel combustion) in Serbia?
Offer a very short reply. 0.34. What is the ratio of the CO2 emissions (% of total fuel combustion) in Low & middle income in 1994 to that in 1995?
Provide a succinct answer. 0.99. What is the ratio of the CO2 emissions (% of total fuel combustion) of Bahrain in 1994 to that in 1995?
Provide a succinct answer. 0.98. What is the ratio of the CO2 emissions (% of total fuel combustion) in Cuba in 1994 to that in 1995?
Give a very brief answer. 1.01. What is the ratio of the CO2 emissions (% of total fuel combustion) of Serbia in 1994 to that in 1995?
Your answer should be very brief. 1.1. What is the ratio of the CO2 emissions (% of total fuel combustion) in Low & middle income in 1994 to that in 1996?
Offer a terse response. 0.92. What is the ratio of the CO2 emissions (% of total fuel combustion) of Bahrain in 1994 to that in 1996?
Give a very brief answer. 0.99. What is the ratio of the CO2 emissions (% of total fuel combustion) in Cuba in 1994 to that in 1996?
Your answer should be compact. 0.99. What is the ratio of the CO2 emissions (% of total fuel combustion) of Serbia in 1994 to that in 1996?
Your answer should be very brief. 0.76. What is the ratio of the CO2 emissions (% of total fuel combustion) in Low & middle income in 1994 to that in 1997?
Keep it short and to the point. 0.92. What is the ratio of the CO2 emissions (% of total fuel combustion) of Bahrain in 1994 to that in 1997?
Keep it short and to the point. 0.97. What is the ratio of the CO2 emissions (% of total fuel combustion) of Cuba in 1994 to that in 1997?
Provide a short and direct response. 0.85. What is the ratio of the CO2 emissions (% of total fuel combustion) of Serbia in 1994 to that in 1997?
Offer a very short reply. 0.6. What is the ratio of the CO2 emissions (% of total fuel combustion) in Low & middle income in 1994 to that in 1998?
Provide a succinct answer. 0.92. What is the ratio of the CO2 emissions (% of total fuel combustion) of Bahrain in 1994 to that in 1998?
Your answer should be compact. 0.97. What is the ratio of the CO2 emissions (% of total fuel combustion) of Cuba in 1994 to that in 1998?
Give a very brief answer. 0.93. What is the ratio of the CO2 emissions (% of total fuel combustion) of Serbia in 1994 to that in 1998?
Make the answer very short. 0.78. What is the ratio of the CO2 emissions (% of total fuel combustion) in Low & middle income in 1994 to that in 1999?
Keep it short and to the point. 0.9. What is the ratio of the CO2 emissions (% of total fuel combustion) in Bahrain in 1994 to that in 1999?
Your answer should be compact. 0.94. What is the ratio of the CO2 emissions (% of total fuel combustion) of Cuba in 1994 to that in 1999?
Provide a short and direct response. 1.02. What is the ratio of the CO2 emissions (% of total fuel combustion) in Serbia in 1994 to that in 1999?
Make the answer very short. 1.05. What is the ratio of the CO2 emissions (% of total fuel combustion) in Low & middle income in 1994 to that in 2000?
Your answer should be compact. 0.86. What is the ratio of the CO2 emissions (% of total fuel combustion) in Bahrain in 1994 to that in 2000?
Keep it short and to the point. 0.91. What is the ratio of the CO2 emissions (% of total fuel combustion) of Cuba in 1994 to that in 2000?
Offer a terse response. 1.12. What is the ratio of the CO2 emissions (% of total fuel combustion) in Serbia in 1994 to that in 2000?
Offer a very short reply. 1.25. What is the ratio of the CO2 emissions (% of total fuel combustion) of Low & middle income in 1994 to that in 2001?
Make the answer very short. 0.85. What is the ratio of the CO2 emissions (% of total fuel combustion) of Bahrain in 1994 to that in 2001?
Ensure brevity in your answer.  0.91. What is the ratio of the CO2 emissions (% of total fuel combustion) of Cuba in 1994 to that in 2001?
Offer a terse response. 1.07. What is the ratio of the CO2 emissions (% of total fuel combustion) in Serbia in 1994 to that in 2001?
Provide a short and direct response. 0.83. What is the ratio of the CO2 emissions (% of total fuel combustion) in Low & middle income in 1995 to that in 1996?
Your answer should be compact. 0.92. What is the ratio of the CO2 emissions (% of total fuel combustion) in Bahrain in 1995 to that in 1996?
Offer a very short reply. 1.02. What is the ratio of the CO2 emissions (% of total fuel combustion) in Cuba in 1995 to that in 1996?
Make the answer very short. 0.98. What is the ratio of the CO2 emissions (% of total fuel combustion) in Serbia in 1995 to that in 1996?
Offer a terse response. 0.69. What is the ratio of the CO2 emissions (% of total fuel combustion) of Low & middle income in 1995 to that in 1997?
Offer a terse response. 0.92. What is the ratio of the CO2 emissions (% of total fuel combustion) in Cuba in 1995 to that in 1997?
Your answer should be very brief. 0.84. What is the ratio of the CO2 emissions (% of total fuel combustion) of Serbia in 1995 to that in 1997?
Make the answer very short. 0.55. What is the ratio of the CO2 emissions (% of total fuel combustion) in Low & middle income in 1995 to that in 1998?
Offer a very short reply. 0.93. What is the ratio of the CO2 emissions (% of total fuel combustion) of Bahrain in 1995 to that in 1998?
Your answer should be very brief. 1. What is the ratio of the CO2 emissions (% of total fuel combustion) of Cuba in 1995 to that in 1998?
Provide a short and direct response. 0.92. What is the ratio of the CO2 emissions (% of total fuel combustion) of Serbia in 1995 to that in 1998?
Make the answer very short. 0.7. What is the ratio of the CO2 emissions (% of total fuel combustion) of Low & middle income in 1995 to that in 1999?
Ensure brevity in your answer.  0.9. What is the ratio of the CO2 emissions (% of total fuel combustion) in Bahrain in 1995 to that in 1999?
Ensure brevity in your answer.  0.97. What is the ratio of the CO2 emissions (% of total fuel combustion) of Cuba in 1995 to that in 1999?
Offer a very short reply. 1.01. What is the ratio of the CO2 emissions (% of total fuel combustion) in Serbia in 1995 to that in 1999?
Offer a terse response. 0.95. What is the ratio of the CO2 emissions (% of total fuel combustion) of Low & middle income in 1995 to that in 2000?
Make the answer very short. 0.87. What is the ratio of the CO2 emissions (% of total fuel combustion) in Bahrain in 1995 to that in 2000?
Your answer should be very brief. 0.94. What is the ratio of the CO2 emissions (% of total fuel combustion) of Cuba in 1995 to that in 2000?
Your answer should be very brief. 1.11. What is the ratio of the CO2 emissions (% of total fuel combustion) in Serbia in 1995 to that in 2000?
Provide a short and direct response. 1.13. What is the ratio of the CO2 emissions (% of total fuel combustion) in Low & middle income in 1995 to that in 2001?
Offer a terse response. 0.86. What is the ratio of the CO2 emissions (% of total fuel combustion) of Bahrain in 1995 to that in 2001?
Give a very brief answer. 0.93. What is the ratio of the CO2 emissions (% of total fuel combustion) of Cuba in 1995 to that in 2001?
Make the answer very short. 1.06. What is the ratio of the CO2 emissions (% of total fuel combustion) in Serbia in 1995 to that in 2001?
Your response must be concise. 0.75. What is the ratio of the CO2 emissions (% of total fuel combustion) in Low & middle income in 1996 to that in 1997?
Offer a terse response. 1. What is the ratio of the CO2 emissions (% of total fuel combustion) of Bahrain in 1996 to that in 1997?
Ensure brevity in your answer.  0.98. What is the ratio of the CO2 emissions (% of total fuel combustion) in Cuba in 1996 to that in 1997?
Offer a terse response. 0.86. What is the ratio of the CO2 emissions (% of total fuel combustion) of Serbia in 1996 to that in 1997?
Your response must be concise. 0.79. What is the ratio of the CO2 emissions (% of total fuel combustion) of Low & middle income in 1996 to that in 1998?
Offer a very short reply. 1.01. What is the ratio of the CO2 emissions (% of total fuel combustion) in Bahrain in 1996 to that in 1998?
Make the answer very short. 0.98. What is the ratio of the CO2 emissions (% of total fuel combustion) of Cuba in 1996 to that in 1998?
Make the answer very short. 0.94. What is the ratio of the CO2 emissions (% of total fuel combustion) of Serbia in 1996 to that in 1998?
Your answer should be compact. 1.02. What is the ratio of the CO2 emissions (% of total fuel combustion) in Low & middle income in 1996 to that in 1999?
Your answer should be compact. 0.98. What is the ratio of the CO2 emissions (% of total fuel combustion) of Bahrain in 1996 to that in 1999?
Keep it short and to the point. 0.95. What is the ratio of the CO2 emissions (% of total fuel combustion) of Cuba in 1996 to that in 1999?
Your response must be concise. 1.03. What is the ratio of the CO2 emissions (% of total fuel combustion) in Serbia in 1996 to that in 1999?
Provide a short and direct response. 1.37. What is the ratio of the CO2 emissions (% of total fuel combustion) in Low & middle income in 1996 to that in 2000?
Provide a succinct answer. 0.94. What is the ratio of the CO2 emissions (% of total fuel combustion) of Bahrain in 1996 to that in 2000?
Make the answer very short. 0.92. What is the ratio of the CO2 emissions (% of total fuel combustion) of Cuba in 1996 to that in 2000?
Your answer should be compact. 1.13. What is the ratio of the CO2 emissions (% of total fuel combustion) of Serbia in 1996 to that in 2000?
Make the answer very short. 1.64. What is the ratio of the CO2 emissions (% of total fuel combustion) in Low & middle income in 1996 to that in 2001?
Provide a short and direct response. 0.93. What is the ratio of the CO2 emissions (% of total fuel combustion) of Bahrain in 1996 to that in 2001?
Make the answer very short. 0.91. What is the ratio of the CO2 emissions (% of total fuel combustion) in Cuba in 1996 to that in 2001?
Ensure brevity in your answer.  1.08. What is the ratio of the CO2 emissions (% of total fuel combustion) of Serbia in 1996 to that in 2001?
Keep it short and to the point. 1.08. What is the ratio of the CO2 emissions (% of total fuel combustion) of Bahrain in 1997 to that in 1998?
Keep it short and to the point. 1. What is the ratio of the CO2 emissions (% of total fuel combustion) of Cuba in 1997 to that in 1998?
Ensure brevity in your answer.  1.09. What is the ratio of the CO2 emissions (% of total fuel combustion) in Serbia in 1997 to that in 1998?
Provide a short and direct response. 1.29. What is the ratio of the CO2 emissions (% of total fuel combustion) of Low & middle income in 1997 to that in 1999?
Your answer should be compact. 0.98. What is the ratio of the CO2 emissions (% of total fuel combustion) in Bahrain in 1997 to that in 1999?
Keep it short and to the point. 0.97. What is the ratio of the CO2 emissions (% of total fuel combustion) in Cuba in 1997 to that in 1999?
Make the answer very short. 1.2. What is the ratio of the CO2 emissions (% of total fuel combustion) in Serbia in 1997 to that in 1999?
Keep it short and to the point. 1.73. What is the ratio of the CO2 emissions (% of total fuel combustion) in Low & middle income in 1997 to that in 2000?
Make the answer very short. 0.94. What is the ratio of the CO2 emissions (% of total fuel combustion) of Bahrain in 1997 to that in 2000?
Your response must be concise. 0.94. What is the ratio of the CO2 emissions (% of total fuel combustion) in Cuba in 1997 to that in 2000?
Your answer should be compact. 1.31. What is the ratio of the CO2 emissions (% of total fuel combustion) in Serbia in 1997 to that in 2000?
Give a very brief answer. 2.07. What is the ratio of the CO2 emissions (% of total fuel combustion) of Low & middle income in 1997 to that in 2001?
Your response must be concise. 0.93. What is the ratio of the CO2 emissions (% of total fuel combustion) in Bahrain in 1997 to that in 2001?
Your answer should be very brief. 0.93. What is the ratio of the CO2 emissions (% of total fuel combustion) in Cuba in 1997 to that in 2001?
Provide a short and direct response. 1.26. What is the ratio of the CO2 emissions (% of total fuel combustion) of Serbia in 1997 to that in 2001?
Give a very brief answer. 1.37. What is the ratio of the CO2 emissions (% of total fuel combustion) in Low & middle income in 1998 to that in 1999?
Keep it short and to the point. 0.97. What is the ratio of the CO2 emissions (% of total fuel combustion) in Bahrain in 1998 to that in 1999?
Provide a succinct answer. 0.97. What is the ratio of the CO2 emissions (% of total fuel combustion) of Cuba in 1998 to that in 1999?
Keep it short and to the point. 1.1. What is the ratio of the CO2 emissions (% of total fuel combustion) in Serbia in 1998 to that in 1999?
Give a very brief answer. 1.35. What is the ratio of the CO2 emissions (% of total fuel combustion) of Bahrain in 1998 to that in 2000?
Provide a succinct answer. 0.94. What is the ratio of the CO2 emissions (% of total fuel combustion) in Cuba in 1998 to that in 2000?
Your answer should be very brief. 1.2. What is the ratio of the CO2 emissions (% of total fuel combustion) of Serbia in 1998 to that in 2000?
Ensure brevity in your answer.  1.61. What is the ratio of the CO2 emissions (% of total fuel combustion) of Low & middle income in 1998 to that in 2001?
Your response must be concise. 0.92. What is the ratio of the CO2 emissions (% of total fuel combustion) of Bahrain in 1998 to that in 2001?
Your answer should be very brief. 0.93. What is the ratio of the CO2 emissions (% of total fuel combustion) of Cuba in 1998 to that in 2001?
Offer a very short reply. 1.15. What is the ratio of the CO2 emissions (% of total fuel combustion) in Serbia in 1998 to that in 2001?
Provide a short and direct response. 1.06. What is the ratio of the CO2 emissions (% of total fuel combustion) of Low & middle income in 1999 to that in 2000?
Make the answer very short. 0.96. What is the ratio of the CO2 emissions (% of total fuel combustion) of Bahrain in 1999 to that in 2000?
Give a very brief answer. 0.97. What is the ratio of the CO2 emissions (% of total fuel combustion) of Cuba in 1999 to that in 2000?
Offer a very short reply. 1.1. What is the ratio of the CO2 emissions (% of total fuel combustion) of Serbia in 1999 to that in 2000?
Your answer should be compact. 1.19. What is the ratio of the CO2 emissions (% of total fuel combustion) of Low & middle income in 1999 to that in 2001?
Your answer should be compact. 0.95. What is the ratio of the CO2 emissions (% of total fuel combustion) in Bahrain in 1999 to that in 2001?
Ensure brevity in your answer.  0.96. What is the ratio of the CO2 emissions (% of total fuel combustion) of Cuba in 1999 to that in 2001?
Keep it short and to the point. 1.05. What is the ratio of the CO2 emissions (% of total fuel combustion) in Serbia in 1999 to that in 2001?
Your answer should be very brief. 0.79. What is the ratio of the CO2 emissions (% of total fuel combustion) of Bahrain in 2000 to that in 2001?
Provide a short and direct response. 0.99. What is the ratio of the CO2 emissions (% of total fuel combustion) of Cuba in 2000 to that in 2001?
Offer a terse response. 0.96. What is the ratio of the CO2 emissions (% of total fuel combustion) of Serbia in 2000 to that in 2001?
Your answer should be compact. 0.66. What is the difference between the highest and the second highest CO2 emissions (% of total fuel combustion) of Low & middle income?
Give a very brief answer. 0.14. What is the difference between the highest and the second highest CO2 emissions (% of total fuel combustion) of Bahrain?
Make the answer very short. 0.07. What is the difference between the highest and the second highest CO2 emissions (% of total fuel combustion) in Cuba?
Provide a succinct answer. 0.89. What is the difference between the highest and the second highest CO2 emissions (% of total fuel combustion) in Serbia?
Make the answer very short. 2.33. What is the difference between the highest and the lowest CO2 emissions (% of total fuel combustion) in Low & middle income?
Make the answer very short. 2.33. What is the difference between the highest and the lowest CO2 emissions (% of total fuel combustion) in Bahrain?
Your response must be concise. 0.81. What is the difference between the highest and the lowest CO2 emissions (% of total fuel combustion) of Cuba?
Your answer should be compact. 2.56. What is the difference between the highest and the lowest CO2 emissions (% of total fuel combustion) in Serbia?
Make the answer very short. 5.79. 